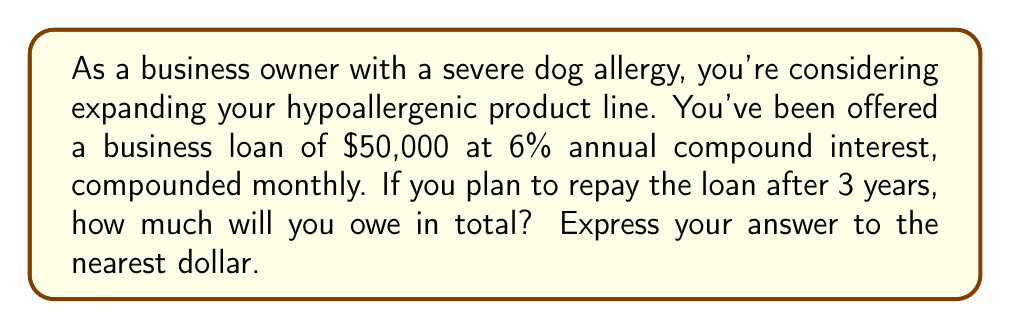Show me your answer to this math problem. To solve this problem, we'll use the compound interest formula, which is a geometric sequence:

$$A = P(1 + \frac{r}{n})^{nt}$$

Where:
$A$ = Final amount
$P$ = Principal (initial loan amount)
$r$ = Annual interest rate (as a decimal)
$n$ = Number of times interest is compounded per year
$t$ = Number of years

Given:
$P = 50,000$
$r = 0.06$ (6% as a decimal)
$n = 12$ (compounded monthly)
$t = 3$ years

Let's substitute these values into the formula:

$$A = 50,000(1 + \frac{0.06}{12})^{12 \cdot 3}$$

$$A = 50,000(1 + 0.005)^{36}$$

$$A = 50,000(1.005)^{36}$$

Using a calculator:

$$A = 50,000 \cdot 1.1956$$

$$A = 59,780.37$$

Rounding to the nearest dollar:

$$A \approx 59,780$$
Answer: $59,780 